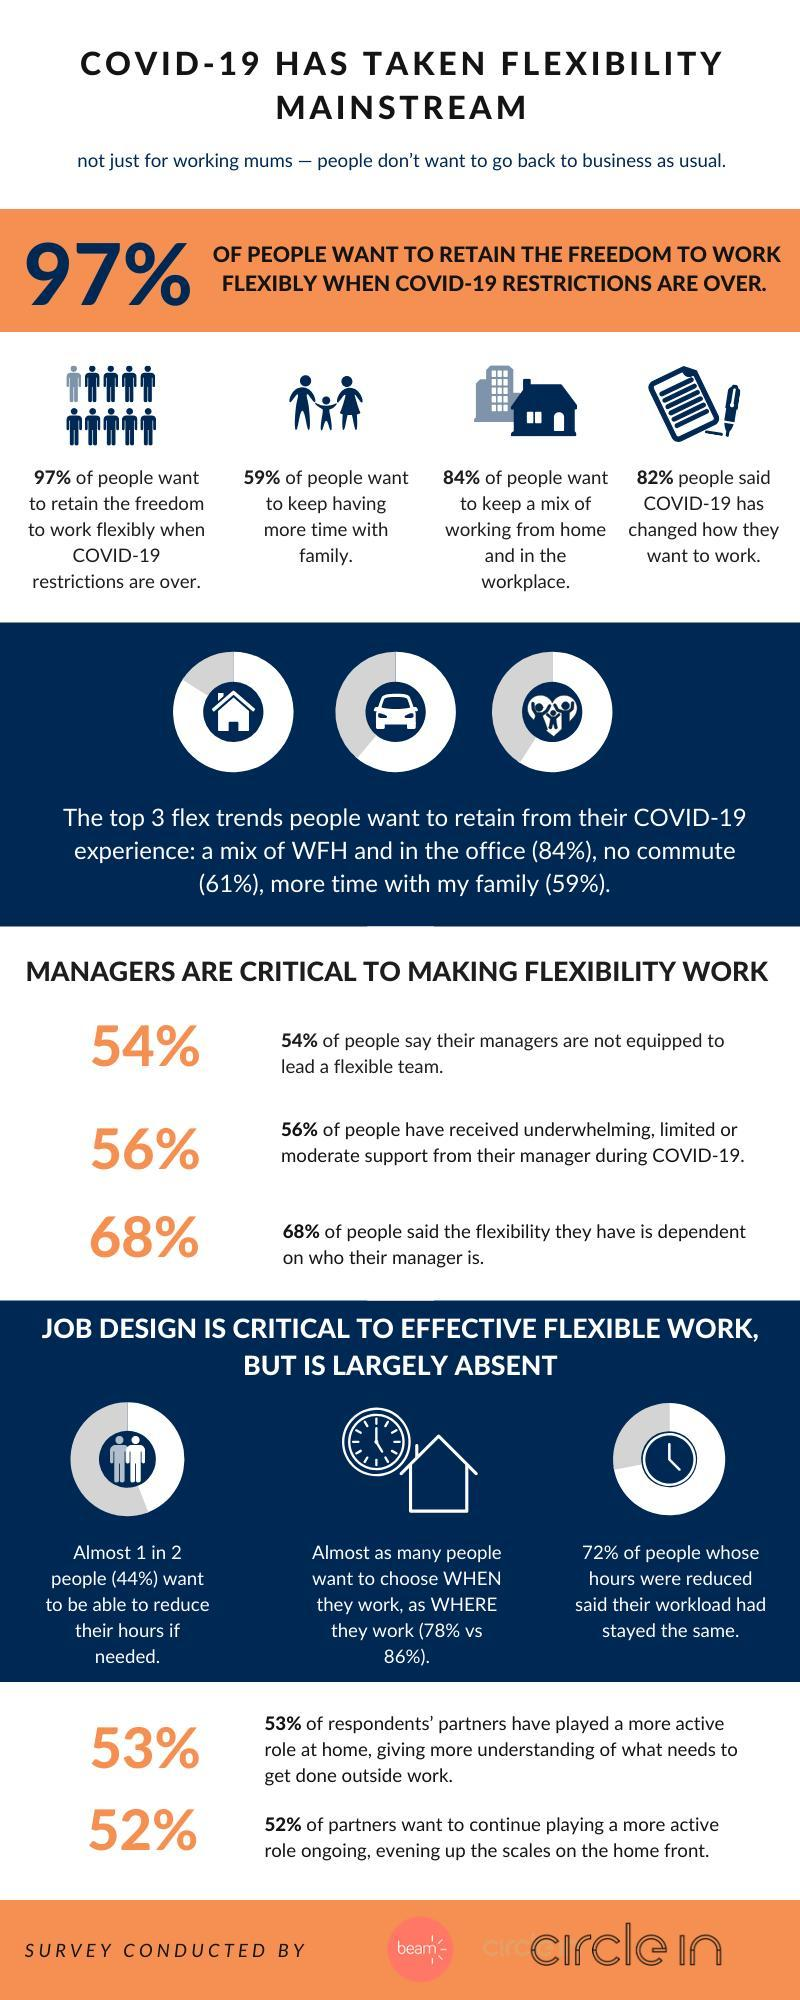How much higher is the % of people who think that flexibility is dependent on their manager that those who think that their manager is not equipped
Answer the question with a short phrase. 14 What % of people want to keep having more time with family 59% In the top 3 flex trends people want to retain from COVID 19 experience, what does the car indicate no commute When it comes to work, what choice does the clock and the house indicate when they work, as where they work How many people think that their workload has not changed 72% 